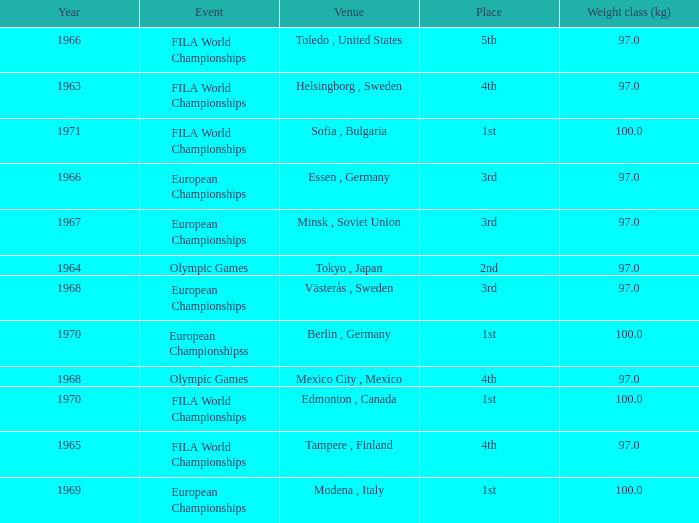What is the lowest weight class (kg) that has sofia, bulgaria as the venue? 100.0. 